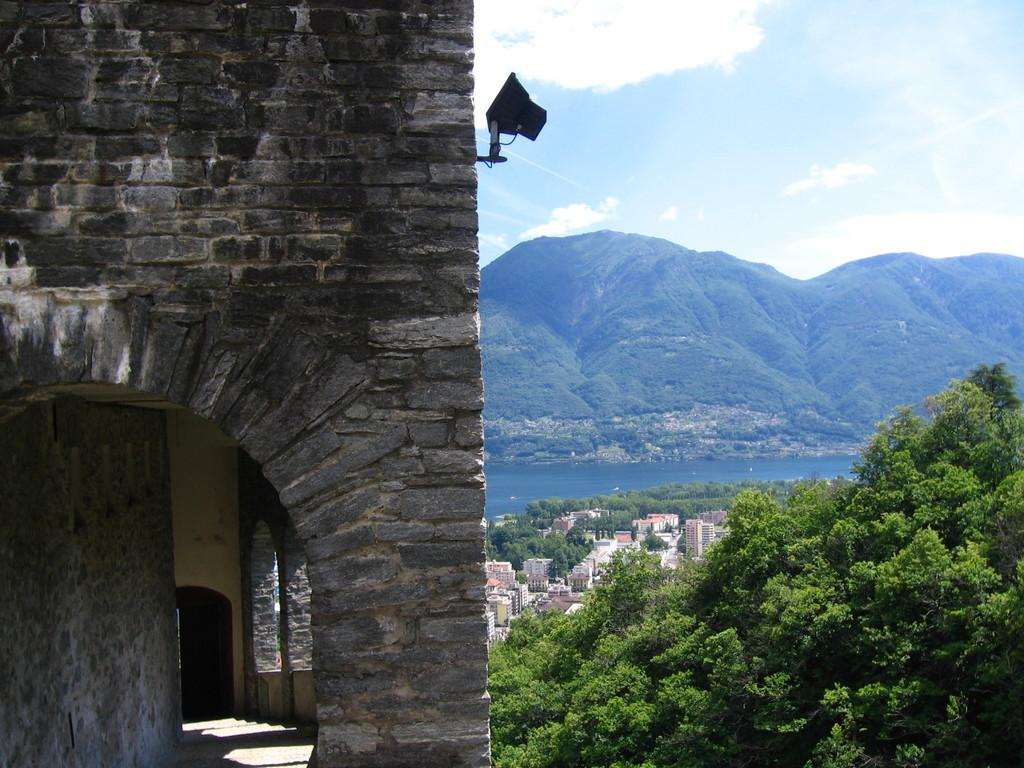What type of structures can be seen in the image? There are buildings in the image. Are there any additional features on the buildings? Yes, there are lights attached to the buildings. What other natural elements can be seen in the image? There are trees, mountains, and water visible in the image. What is visible in the background of the image? The sky is visible in the image. What type of arch can be seen in the image? There is no arch present in the image. What flavor of cream is visible in the image? There is no cream present in the image. 